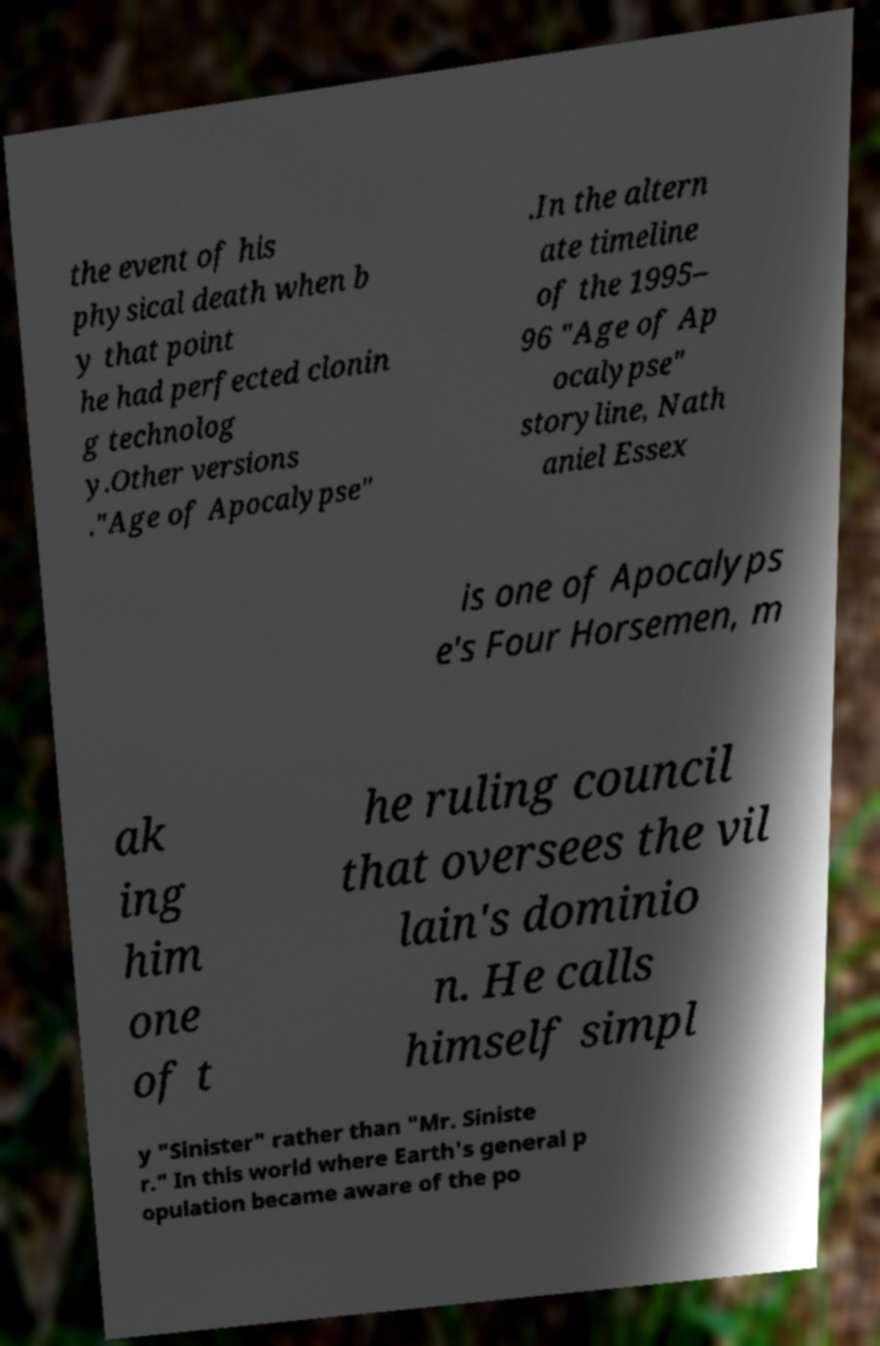I need the written content from this picture converted into text. Can you do that? the event of his physical death when b y that point he had perfected clonin g technolog y.Other versions ."Age of Apocalypse" .In the altern ate timeline of the 1995– 96 "Age of Ap ocalypse" storyline, Nath aniel Essex is one of Apocalyps e's Four Horsemen, m ak ing him one of t he ruling council that oversees the vil lain's dominio n. He calls himself simpl y "Sinister" rather than "Mr. Siniste r." In this world where Earth's general p opulation became aware of the po 